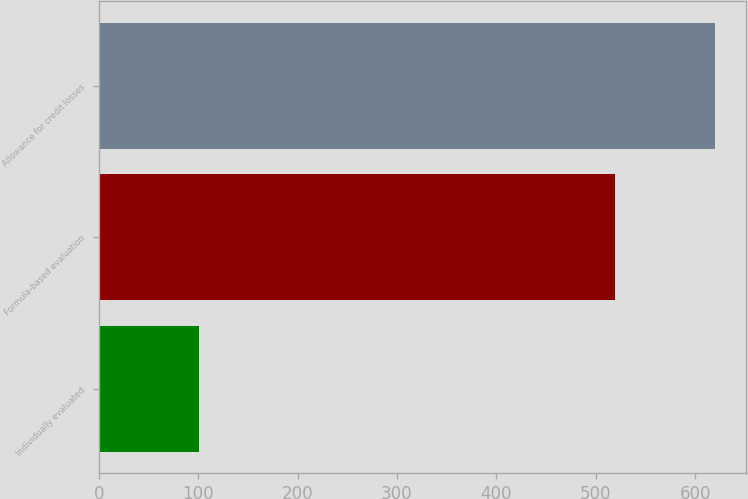Convert chart. <chart><loc_0><loc_0><loc_500><loc_500><bar_chart><fcel>Individually evaluated<fcel>Formula-based evaluation<fcel>Allowance for credit losses<nl><fcel>101<fcel>519<fcel>620<nl></chart> 